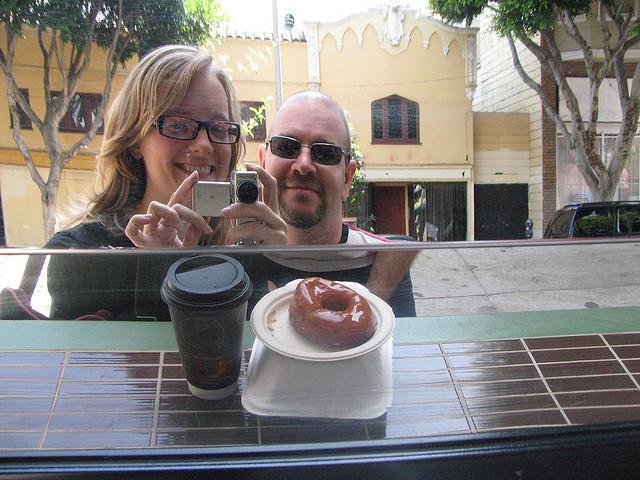How many doughnuts?
Give a very brief answer. 1. How many people are there?
Give a very brief answer. 2. 